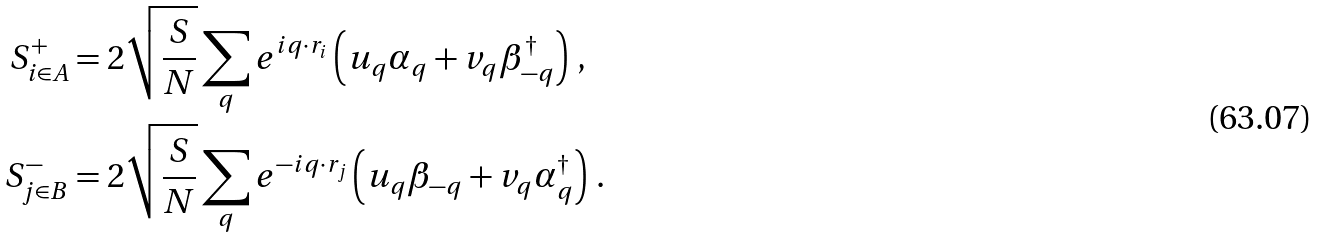Convert formula to latex. <formula><loc_0><loc_0><loc_500><loc_500>S _ { i \in A } ^ { + } & = 2 \sqrt { \frac { S } { N } } \sum _ { q } { e ^ { i { q } \cdot { r } _ { i } } \left ( u _ { q } \alpha _ { q } + v _ { q } \beta _ { - { q } } ^ { \dag } \right ) } \ , \\ S _ { j \in B } ^ { - } & = 2 \sqrt { \frac { S } { N } } \sum _ { q } { e ^ { - i { q } \cdot { r } _ { j } } \left ( u _ { q } \beta _ { - { q } } + v _ { q } \alpha _ { q } ^ { \dag } \right ) } \ .</formula> 